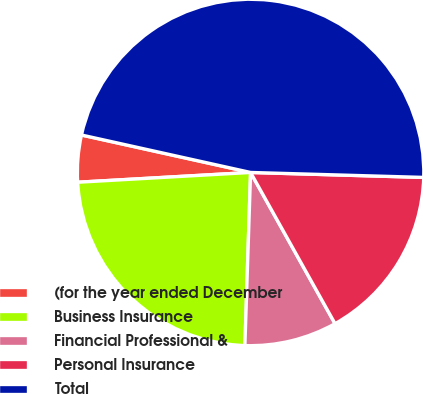Convert chart. <chart><loc_0><loc_0><loc_500><loc_500><pie_chart><fcel>(for the year ended December<fcel>Business Insurance<fcel>Financial Professional &<fcel>Personal Insurance<fcel>Total<nl><fcel>4.37%<fcel>23.58%<fcel>8.63%<fcel>16.44%<fcel>46.99%<nl></chart> 